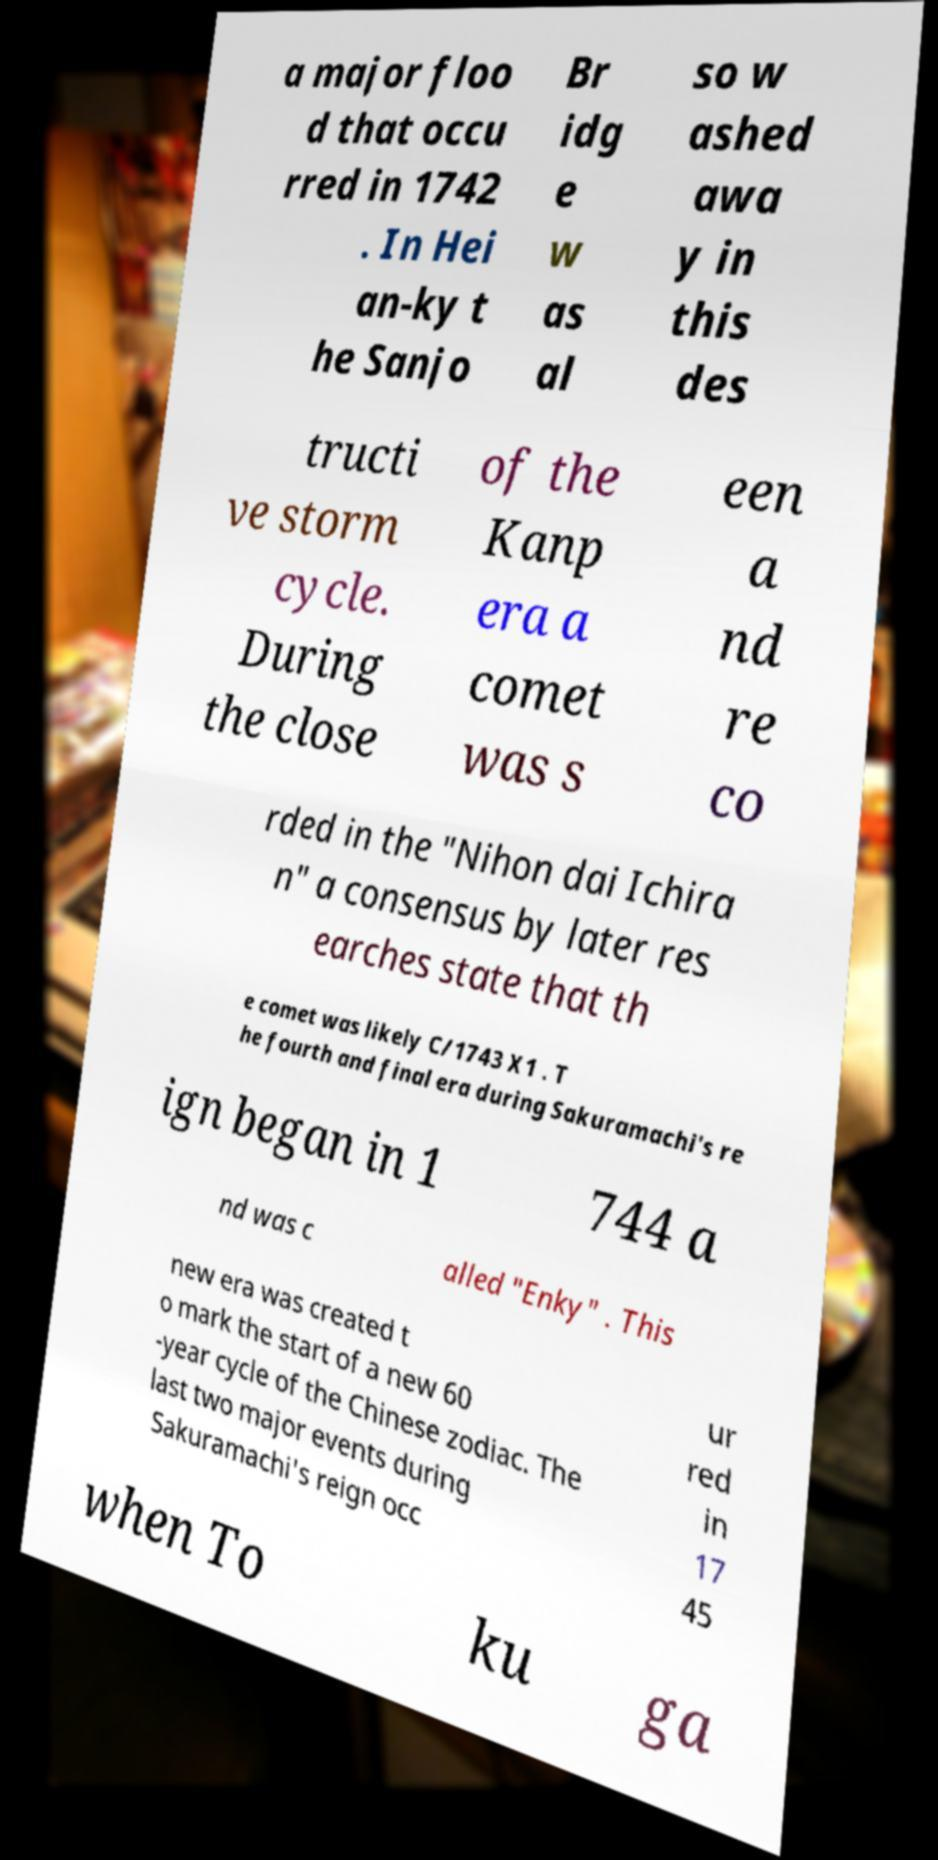Could you extract and type out the text from this image? a major floo d that occu rred in 1742 . In Hei an-ky t he Sanjo Br idg e w as al so w ashed awa y in this des tructi ve storm cycle. During the close of the Kanp era a comet was s een a nd re co rded in the "Nihon dai Ichira n" a consensus by later res earches state that th e comet was likely C/1743 X1 . T he fourth and final era during Sakuramachi's re ign began in 1 744 a nd was c alled "Enky" . This new era was created t o mark the start of a new 60 -year cycle of the Chinese zodiac. The last two major events during Sakuramachi's reign occ ur red in 17 45 when To ku ga 